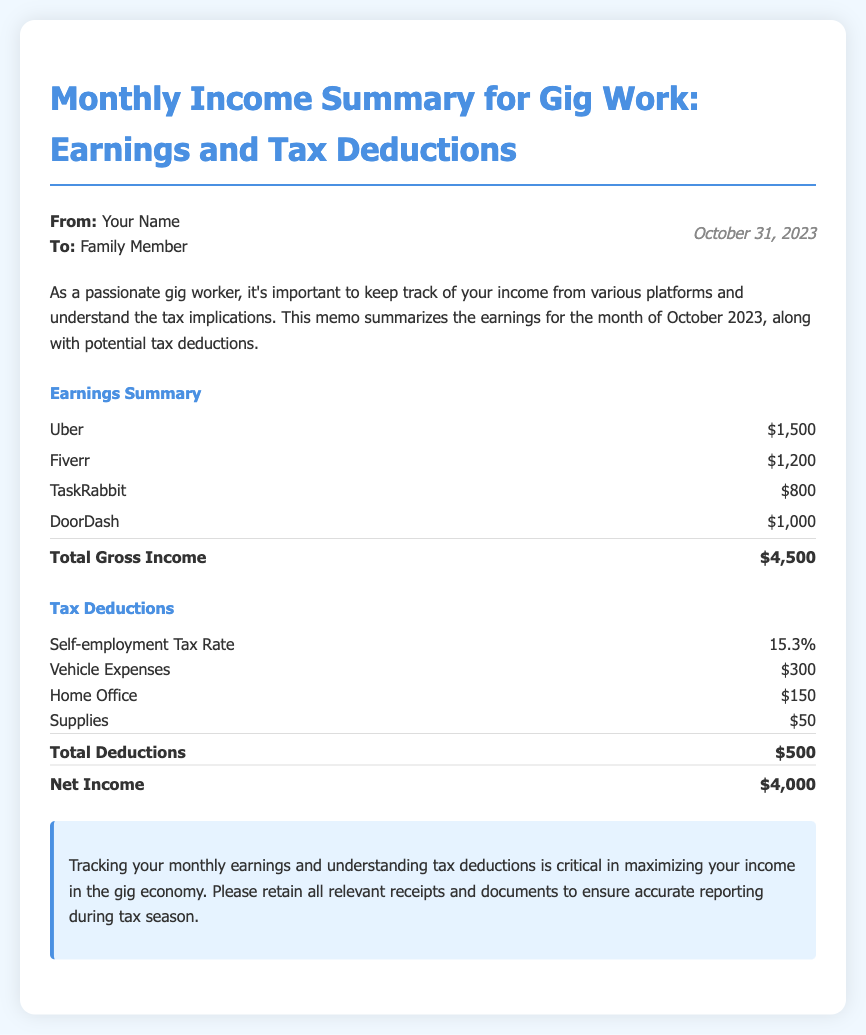What is the total gross income for October 2023? The total gross income is calculated by adding the earnings from all platforms mentioned in the document, which amounts to $4,500.
Answer: $4,500 What was the earning from Fiverr? The document lists the earning from Fiverr specifically as $1,200.
Answer: $1,200 How much is deducted for vehicle expenses? The document states that vehicle expenses amount to $300 as a tax deduction.
Answer: $300 What is the net income after tax deductions? The net income is derived after deducting total deductions from gross income, leading to $4,000 as stated in the document.
Answer: $4,000 What percentage is the self-employment tax rate? The document specifies that the self-employment tax rate is 15.3%.
Answer: 15.3% What platforms contributed to the earnings in October? The document lists the platforms that contributed to earnings, which include Uber, Fiverr, TaskRabbit, and DoorDash.
Answer: Uber, Fiverr, TaskRabbit, DoorDash What is the total amount for tax deductions? The document indicates the total deductions amount to $500.
Answer: $500 Why is it important to track earnings and deductions in gig work? The conclusion emphasizes that tracking earnings and tax deductions is critical for maximizing income in the gig economy.
Answer: To maximize income in the gig economy What date is the memo dated? The document indicates that the memo is dated October 31, 2023.
Answer: October 31, 2023 